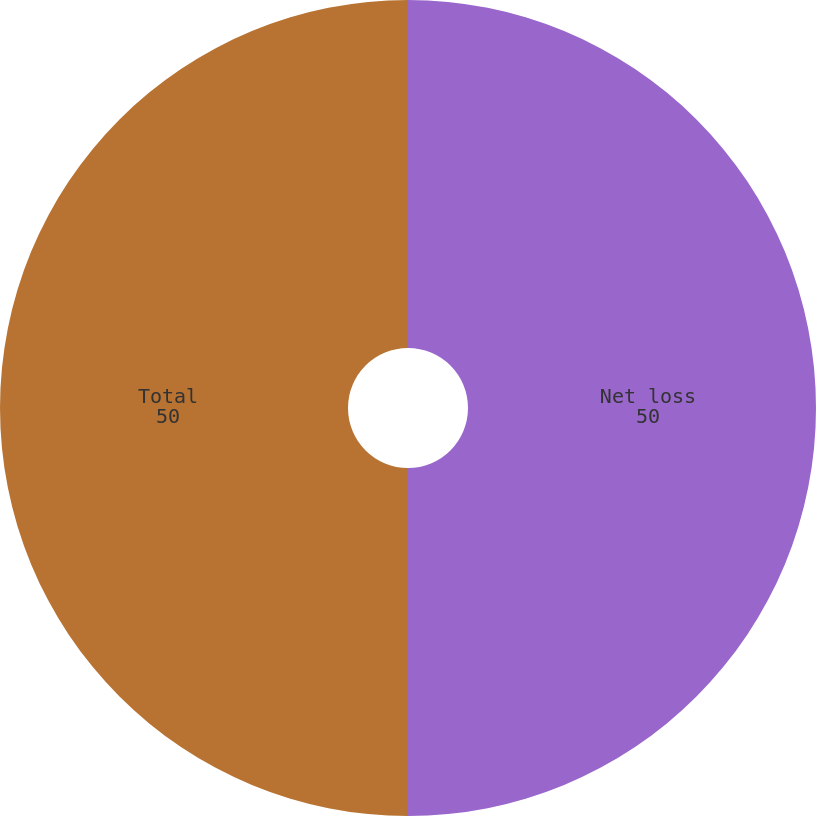Convert chart to OTSL. <chart><loc_0><loc_0><loc_500><loc_500><pie_chart><fcel>Net loss<fcel>Total<nl><fcel>50.0%<fcel>50.0%<nl></chart> 